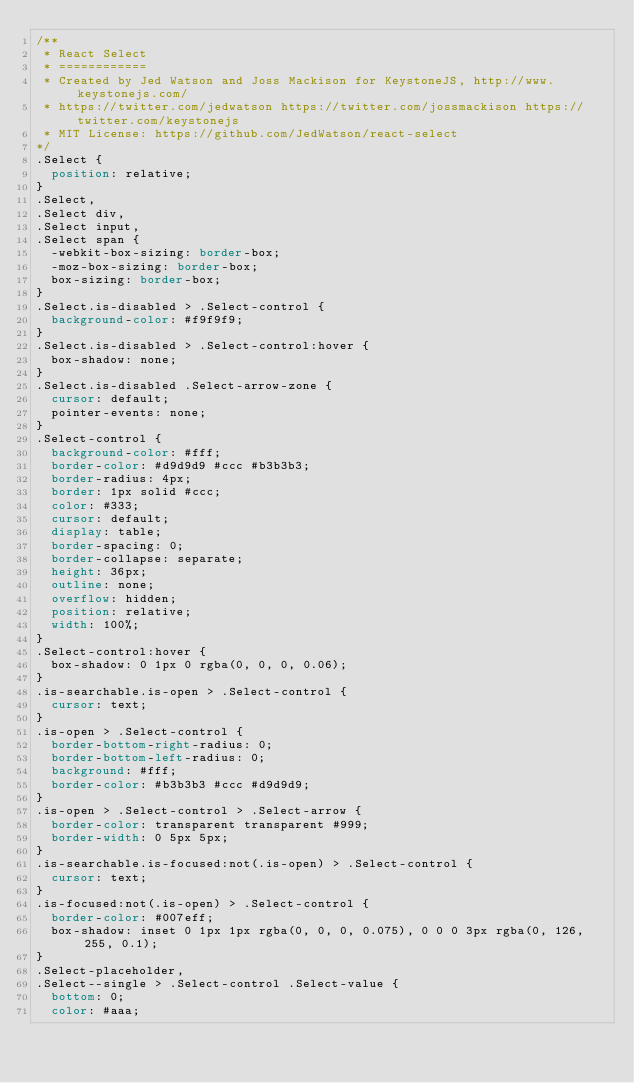<code> <loc_0><loc_0><loc_500><loc_500><_CSS_>/**
 * React Select
 * ============
 * Created by Jed Watson and Joss Mackison for KeystoneJS, http://www.keystonejs.com/
 * https://twitter.com/jedwatson https://twitter.com/jossmackison https://twitter.com/keystonejs
 * MIT License: https://github.com/JedWatson/react-select
*/
.Select {
  position: relative;
}
.Select,
.Select div,
.Select input,
.Select span {
  -webkit-box-sizing: border-box;
  -moz-box-sizing: border-box;
  box-sizing: border-box;
}
.Select.is-disabled > .Select-control {
  background-color: #f9f9f9;
}
.Select.is-disabled > .Select-control:hover {
  box-shadow: none;
}
.Select.is-disabled .Select-arrow-zone {
  cursor: default;
  pointer-events: none;
}
.Select-control {
  background-color: #fff;
  border-color: #d9d9d9 #ccc #b3b3b3;
  border-radius: 4px;
  border: 1px solid #ccc;
  color: #333;
  cursor: default;
  display: table;
  border-spacing: 0;
  border-collapse: separate;
  height: 36px;
  outline: none;
  overflow: hidden;
  position: relative;
  width: 100%;
}
.Select-control:hover {
  box-shadow: 0 1px 0 rgba(0, 0, 0, 0.06);
}
.is-searchable.is-open > .Select-control {
  cursor: text;
}
.is-open > .Select-control {
  border-bottom-right-radius: 0;
  border-bottom-left-radius: 0;
  background: #fff;
  border-color: #b3b3b3 #ccc #d9d9d9;
}
.is-open > .Select-control > .Select-arrow {
  border-color: transparent transparent #999;
  border-width: 0 5px 5px;
}
.is-searchable.is-focused:not(.is-open) > .Select-control {
  cursor: text;
}
.is-focused:not(.is-open) > .Select-control {
  border-color: #007eff;
  box-shadow: inset 0 1px 1px rgba(0, 0, 0, 0.075), 0 0 0 3px rgba(0, 126, 255, 0.1);
}
.Select-placeholder,
.Select--single > .Select-control .Select-value {
  bottom: 0;
  color: #aaa;</code> 